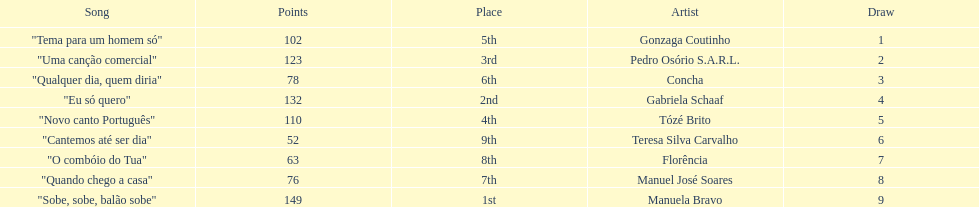Which artist came in last place? Teresa Silva Carvalho. 